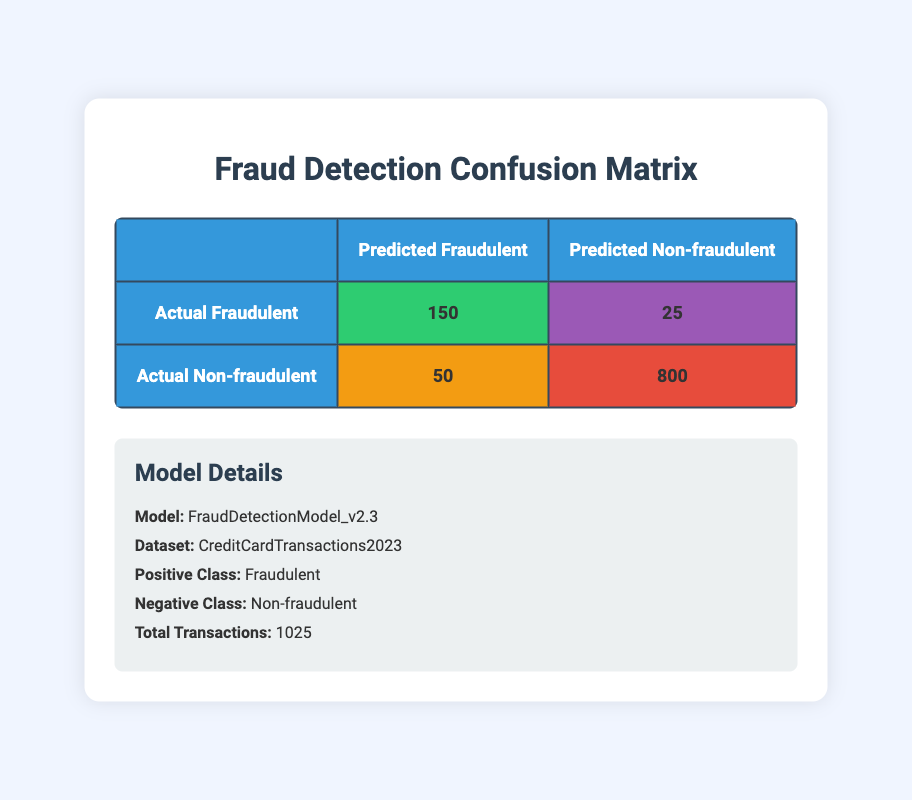What is the total number of true positive predictions? The confusion matrix indicates that there are 150 true positive predictions for fraudulent transactions.
Answer: 150 How many transactions were predicted as non-fraudulent? To find the predicted non-fraudulent transactions, we sum the true negatives and false positives: 800 (true negatives) + 50 (false positives) = 850.
Answer: 850 What is the false negative rate of the model? The false negative rate is calculated as the number of false negatives divided by the total actual positives: 25 (false negatives) / (150 + 25) = 0.1429, or approximately 14.29%.
Answer: 14.29% Is the number of true negatives greater than the number of true positives? Yes, the confusion matrix shows there are 800 true negatives, which is greater than the 150 true positives.
Answer: Yes What percentage of the total transactions were correctly classified as non-fraudulent? To find this percentage, we take the true negatives (800) and divide by the total transactions (1025), then multiply by 100: (800 / 1025) * 100 = 78.05%.
Answer: 78.05% What is the total number of actual fraudulent transactions? The total number of actual fraudulent transactions is the sum of true positives and false negatives: 150 (true positives) + 25 (false negatives) = 175.
Answer: 175 How many predictions were incorrect? Incorrect predictions are the sum of false positives and false negatives: 50 (false positives) + 25 (false negatives) = 75.
Answer: 75 What is the number of actual non-fraudulent transactions? To find the number of actual non-fraudulent transactions, we subtract the actual fraudulent transactions (175) from the total transactions (1025): 1025 - 175 = 850.
Answer: 850 What is the precision of the model? Precision is calculated as true positives divided by the sum of true positives and false positives: 150 / (150 + 50) = 0.75, or 75%.
Answer: 75% 